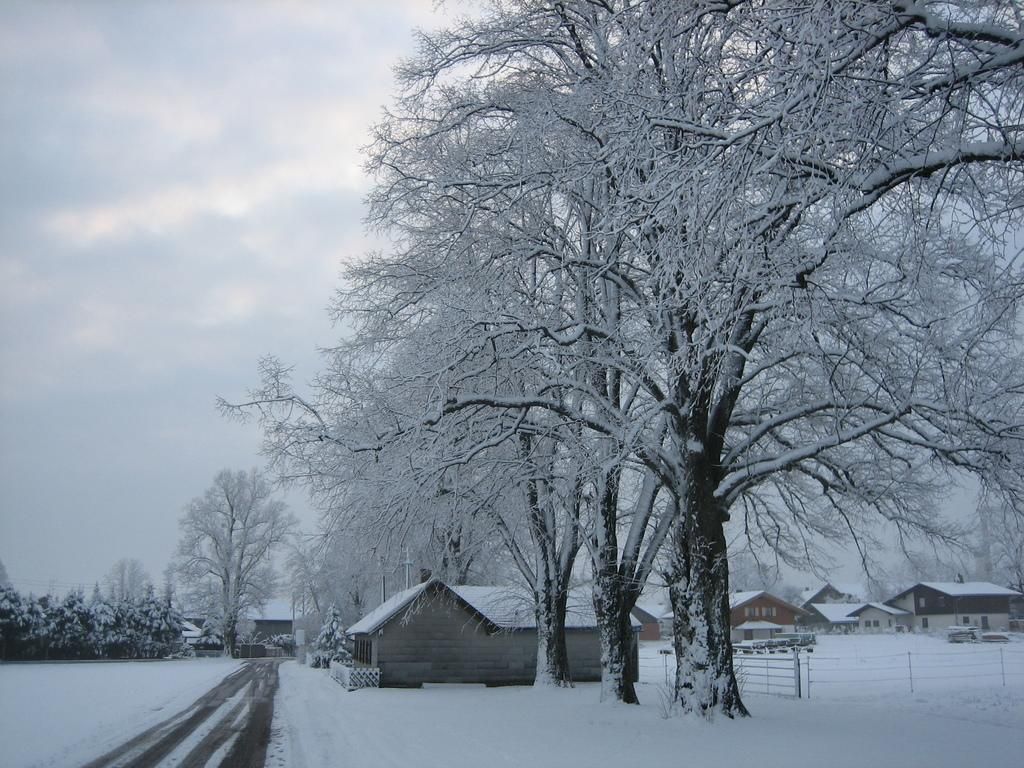What type of vegetation can be seen in the image? There are trees in the image. What type of structures are present in the image? There are houses in the image. What material are the rods in the image made of? The rods in the image are made of metal. What is the weather like in the image? The weather is cold, as there is snow visible in the image. What type of plants are growing under the trees in the image? There is no mention of plants growing under the trees in the image. Can you hear any thunder in the image? There is no sound present in the image, so it is not possible to determine if there is thunder. 